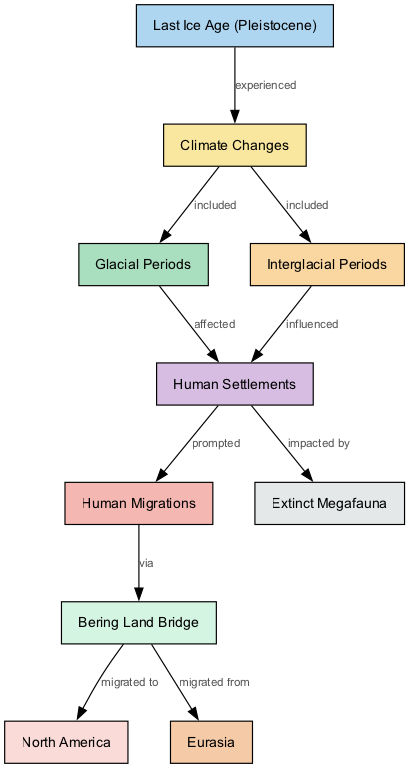What overall period does the diagram represent? The diagram identifies the time frame as the "Last Ice Age (Pleistocene)," as indicated in the first node labeled with this term. Thus, the entire content revolves around understanding phenomena during this period.
Answer: Last Ice Age (Pleistocene) How many nodes are present in the diagram? By counting each distinctly labeled element in the diagram, we identify a total of 10 nodes listed. Each represents a significant factor or aspect concerning climate changes during the Last Ice Age.
Answer: 10 What is the relationship between climate changes and human migrations? According to the diagram, human migrations were "prompted" by human settlements, which in turn were affected or influenced by climate changes. This establishes a direct link between climate shifts and subsequent human behavior regarding migration.
Answer: prompted Which land bridge is mentioned as a migration route? The diagram specifies the "Bering Land Bridge" as the migration route involved for humans moving between Eurasia and North America. This bridge facilitated the migration of early humans due to climatic changes.
Answer: Bering Land Bridge Which type of climate change periods directly affected human settlements? The graph distinguishes "Glacial Periods" as specifically affecting human settlements, showing that the harsh climatic conditions during these times likely influenced where and how humans established their communities.
Answer: Glacial Periods How did climate changes influence human settlements according to the diagram? The diagram shows that climate changes included both glacial and interglacial periods, where the former affected human settlements negatively, while the latter influenced them positively by allowing for resource availability and population growth.
Answer: influenced From where did humans migrate to North America? The diagram indicates that humans migrated to North America "via" the Bering Land Bridge, starting from Eurasia. This highlights the route that ancient humans took due to climate-induced changes impacting land accessibility.
Answer: Eurasia What was significantly impacted by human settlements according to the diagram? The diagram states that human settlements were "impacted by" extinct megafauna, suggesting the interactions between humans and these large animals affected the development and sustainability of early human communities.
Answer: Extinct Megafauna 